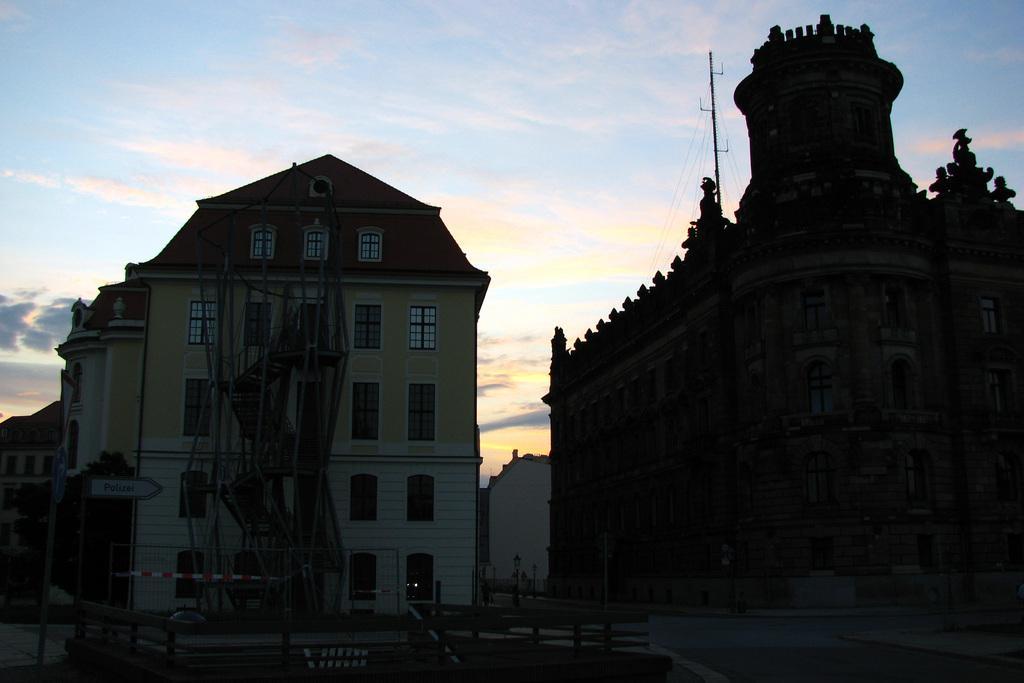In one or two sentences, can you explain what this image depicts? In this image we can see buildings, poles, boards, trees, railing, road, and an object. In the background there is sky with clouds. 